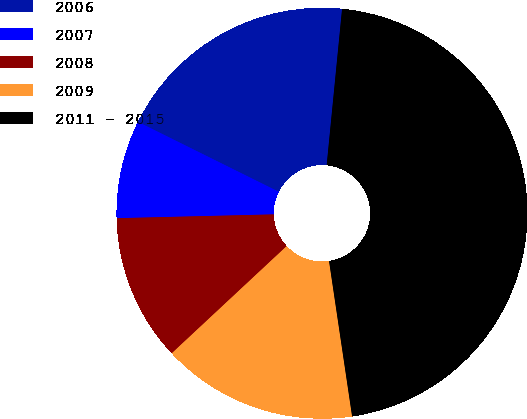Convert chart to OTSL. <chart><loc_0><loc_0><loc_500><loc_500><pie_chart><fcel>2006<fcel>2007<fcel>2008<fcel>2009<fcel>2011 - 2015<nl><fcel>19.23%<fcel>7.72%<fcel>11.56%<fcel>15.4%<fcel>46.09%<nl></chart> 